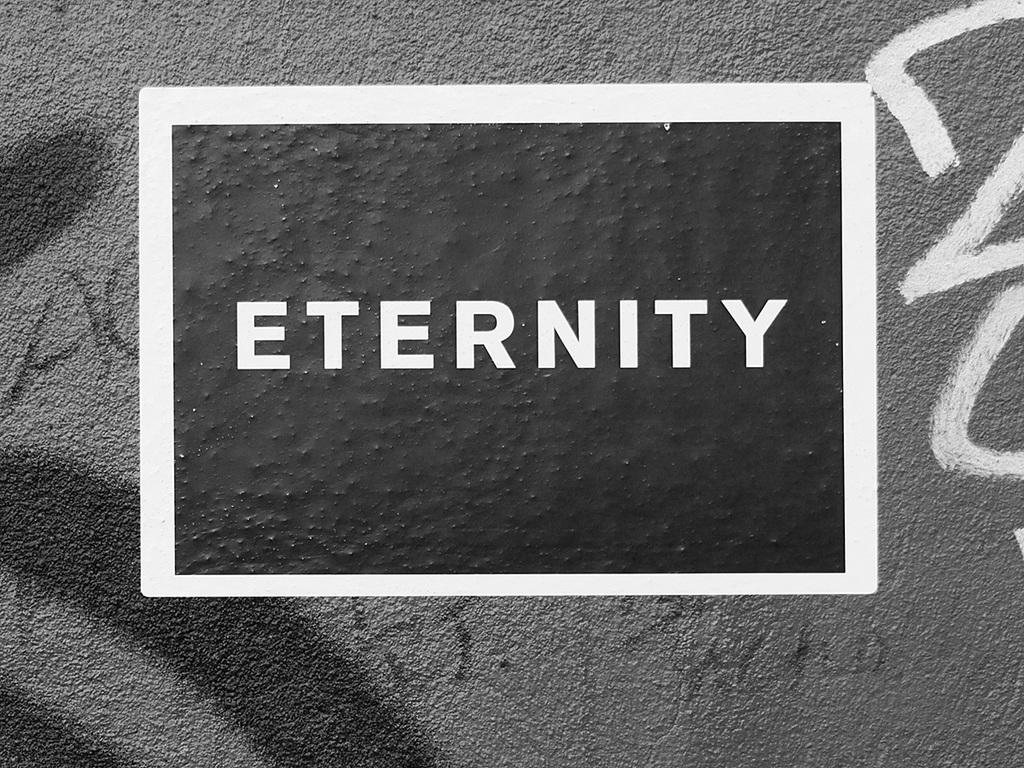<image>
Give a short and clear explanation of the subsequent image. a sign reading Eternity on a wall of grafitti 